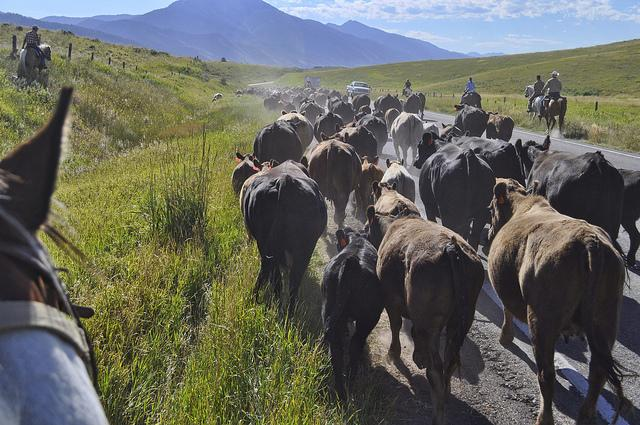What tragedy can happen here? Please explain your reasoning. cows hit. There are cows and cars visibly present and using the same road. in such a setting there could be an incidental collision. 